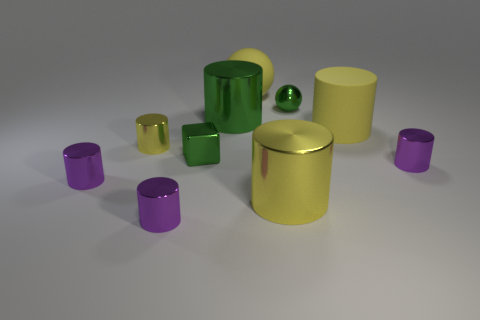There is a yellow metallic cylinder on the left side of the green cylinder; what is its size?
Provide a succinct answer. Small. Is the size of the green shiny sphere that is on the right side of the green cylinder the same as the yellow matte thing on the left side of the green metal ball?
Offer a terse response. No. How many other small green spheres have the same material as the tiny green ball?
Offer a very short reply. 0. What color is the rubber sphere?
Offer a terse response. Yellow. There is a big matte cylinder; are there any tiny yellow shiny things on the left side of it?
Make the answer very short. Yes. Do the metallic sphere and the metallic block have the same color?
Your answer should be very brief. Yes. How many large matte things are the same color as the large ball?
Offer a terse response. 1. What is the size of the purple cylinder that is in front of the large metal object that is on the right side of the green shiny cylinder?
Ensure brevity in your answer.  Small. There is a big green metallic object; what shape is it?
Provide a succinct answer. Cylinder. What is the tiny green object that is behind the small cube made of?
Keep it short and to the point. Metal. 